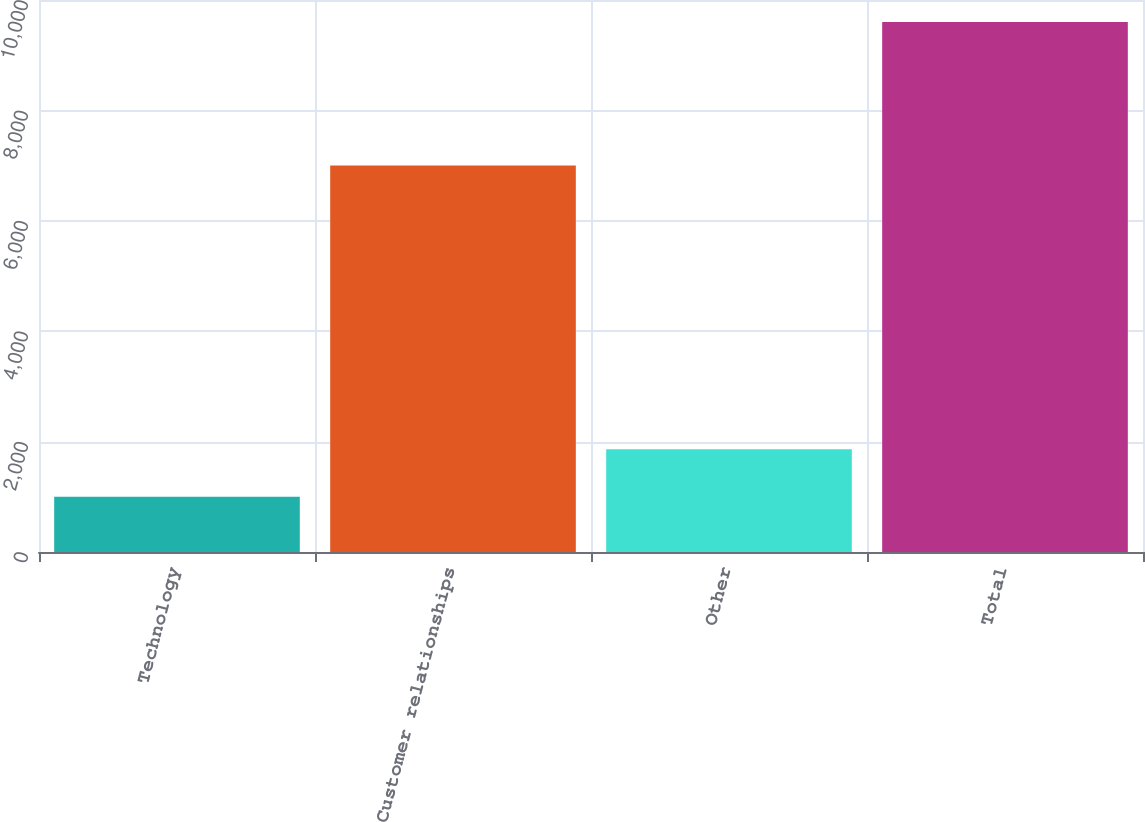Convert chart. <chart><loc_0><loc_0><loc_500><loc_500><bar_chart><fcel>Technology<fcel>Customer relationships<fcel>Other<fcel>Total<nl><fcel>1000<fcel>7000<fcel>1860<fcel>9600<nl></chart> 